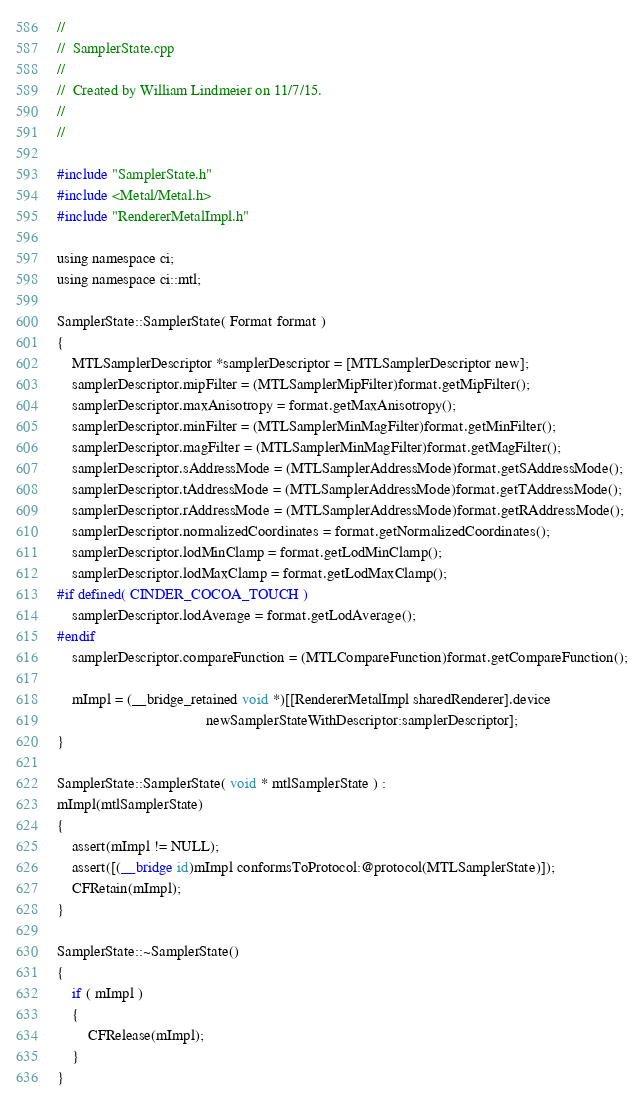Convert code to text. <code><loc_0><loc_0><loc_500><loc_500><_ObjectiveC_>//
//  SamplerState.cpp
//
//  Created by William Lindmeier on 11/7/15.
//
//

#include "SamplerState.h"
#include <Metal/Metal.h>
#include "RendererMetalImpl.h"

using namespace ci;
using namespace ci::mtl;

SamplerState::SamplerState( Format format )
{
    MTLSamplerDescriptor *samplerDescriptor = [MTLSamplerDescriptor new];
    samplerDescriptor.mipFilter = (MTLSamplerMipFilter)format.getMipFilter();
    samplerDescriptor.maxAnisotropy = format.getMaxAnisotropy();
    samplerDescriptor.minFilter = (MTLSamplerMinMagFilter)format.getMinFilter();
    samplerDescriptor.magFilter = (MTLSamplerMinMagFilter)format.getMagFilter();
    samplerDescriptor.sAddressMode = (MTLSamplerAddressMode)format.getSAddressMode();
    samplerDescriptor.tAddressMode = (MTLSamplerAddressMode)format.getTAddressMode();
    samplerDescriptor.rAddressMode = (MTLSamplerAddressMode)format.getRAddressMode();
    samplerDescriptor.normalizedCoordinates = format.getNormalizedCoordinates();
    samplerDescriptor.lodMinClamp = format.getLodMinClamp();
    samplerDescriptor.lodMaxClamp = format.getLodMaxClamp();
#if defined( CINDER_COCOA_TOUCH )
    samplerDescriptor.lodAverage = format.getLodAverage();
#endif
    samplerDescriptor.compareFunction = (MTLCompareFunction)format.getCompareFunction();
    
    mImpl = (__bridge_retained void *)[[RendererMetalImpl sharedRenderer].device
                                       newSamplerStateWithDescriptor:samplerDescriptor];
}

SamplerState::SamplerState( void * mtlSamplerState ) :
mImpl(mtlSamplerState)
{
    assert(mImpl != NULL);
    assert([(__bridge id)mImpl conformsToProtocol:@protocol(MTLSamplerState)]);
    CFRetain(mImpl);
}

SamplerState::~SamplerState()
{
    if ( mImpl )
    {
        CFRelease(mImpl);
    }
}</code> 